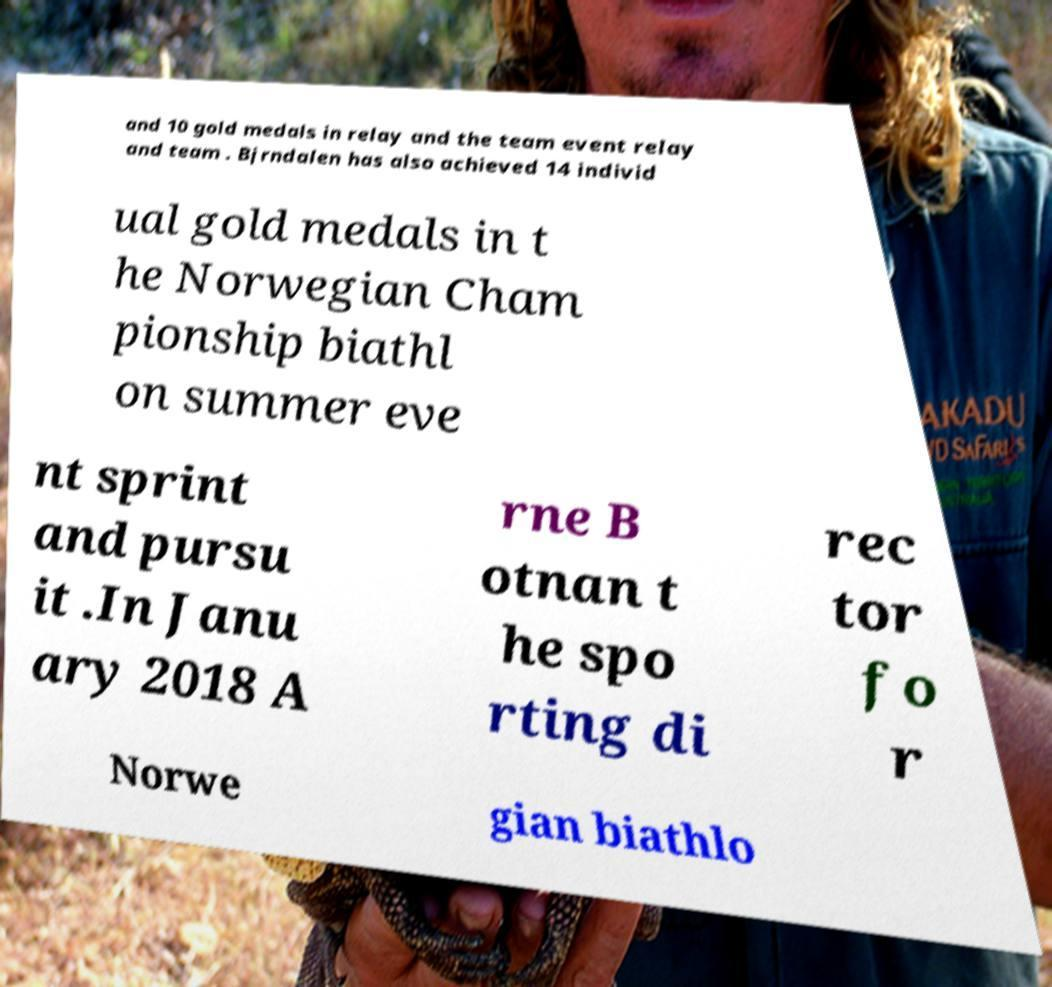There's text embedded in this image that I need extracted. Can you transcribe it verbatim? and 10 gold medals in relay and the team event relay and team . Bjrndalen has also achieved 14 individ ual gold medals in t he Norwegian Cham pionship biathl on summer eve nt sprint and pursu it .In Janu ary 2018 A rne B otnan t he spo rting di rec tor fo r Norwe gian biathlo 